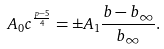<formula> <loc_0><loc_0><loc_500><loc_500>A _ { 0 } c ^ { \frac { p - 5 } { 4 } } = \pm A _ { 1 } \frac { b - b _ { \infty } } { b _ { \infty } } .</formula> 